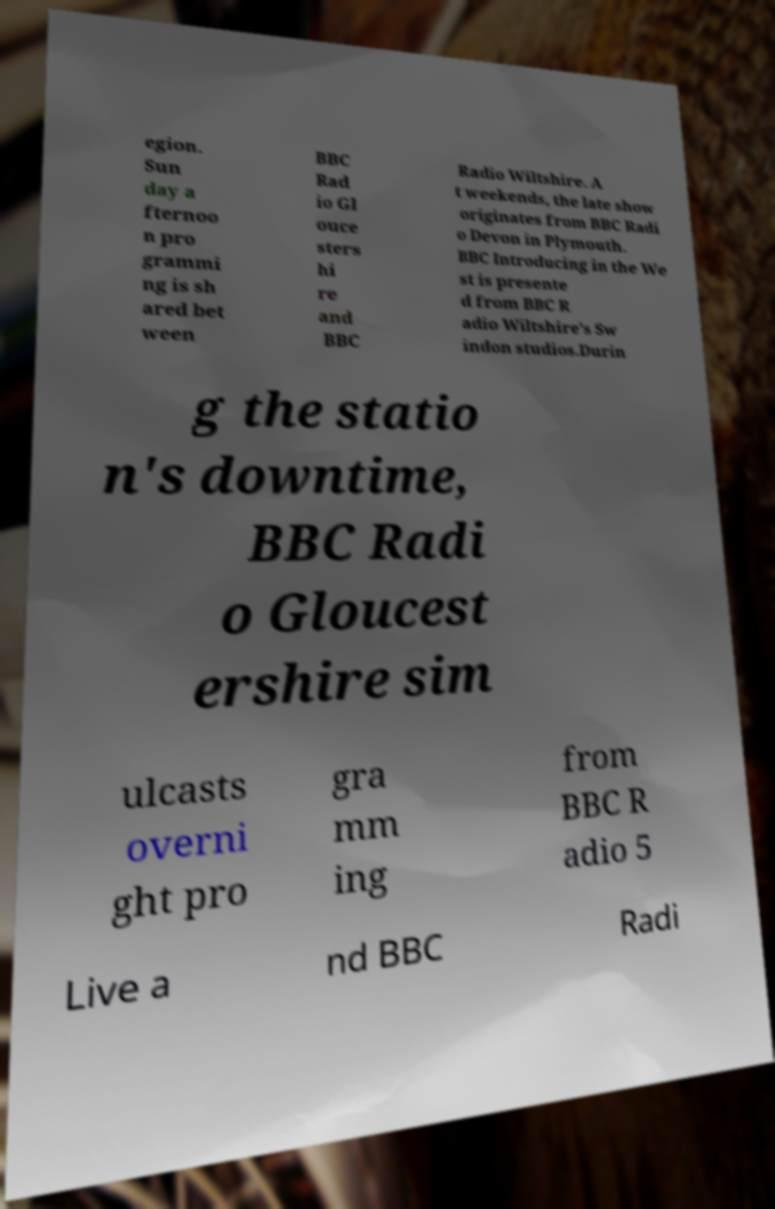What messages or text are displayed in this image? I need them in a readable, typed format. egion. Sun day a fternoo n pro grammi ng is sh ared bet ween BBC Rad io Gl ouce sters hi re and BBC Radio Wiltshire. A t weekends, the late show originates from BBC Radi o Devon in Plymouth. BBC Introducing in the We st is presente d from BBC R adio Wiltshire's Sw indon studios.Durin g the statio n's downtime, BBC Radi o Gloucest ershire sim ulcasts overni ght pro gra mm ing from BBC R adio 5 Live a nd BBC Radi 